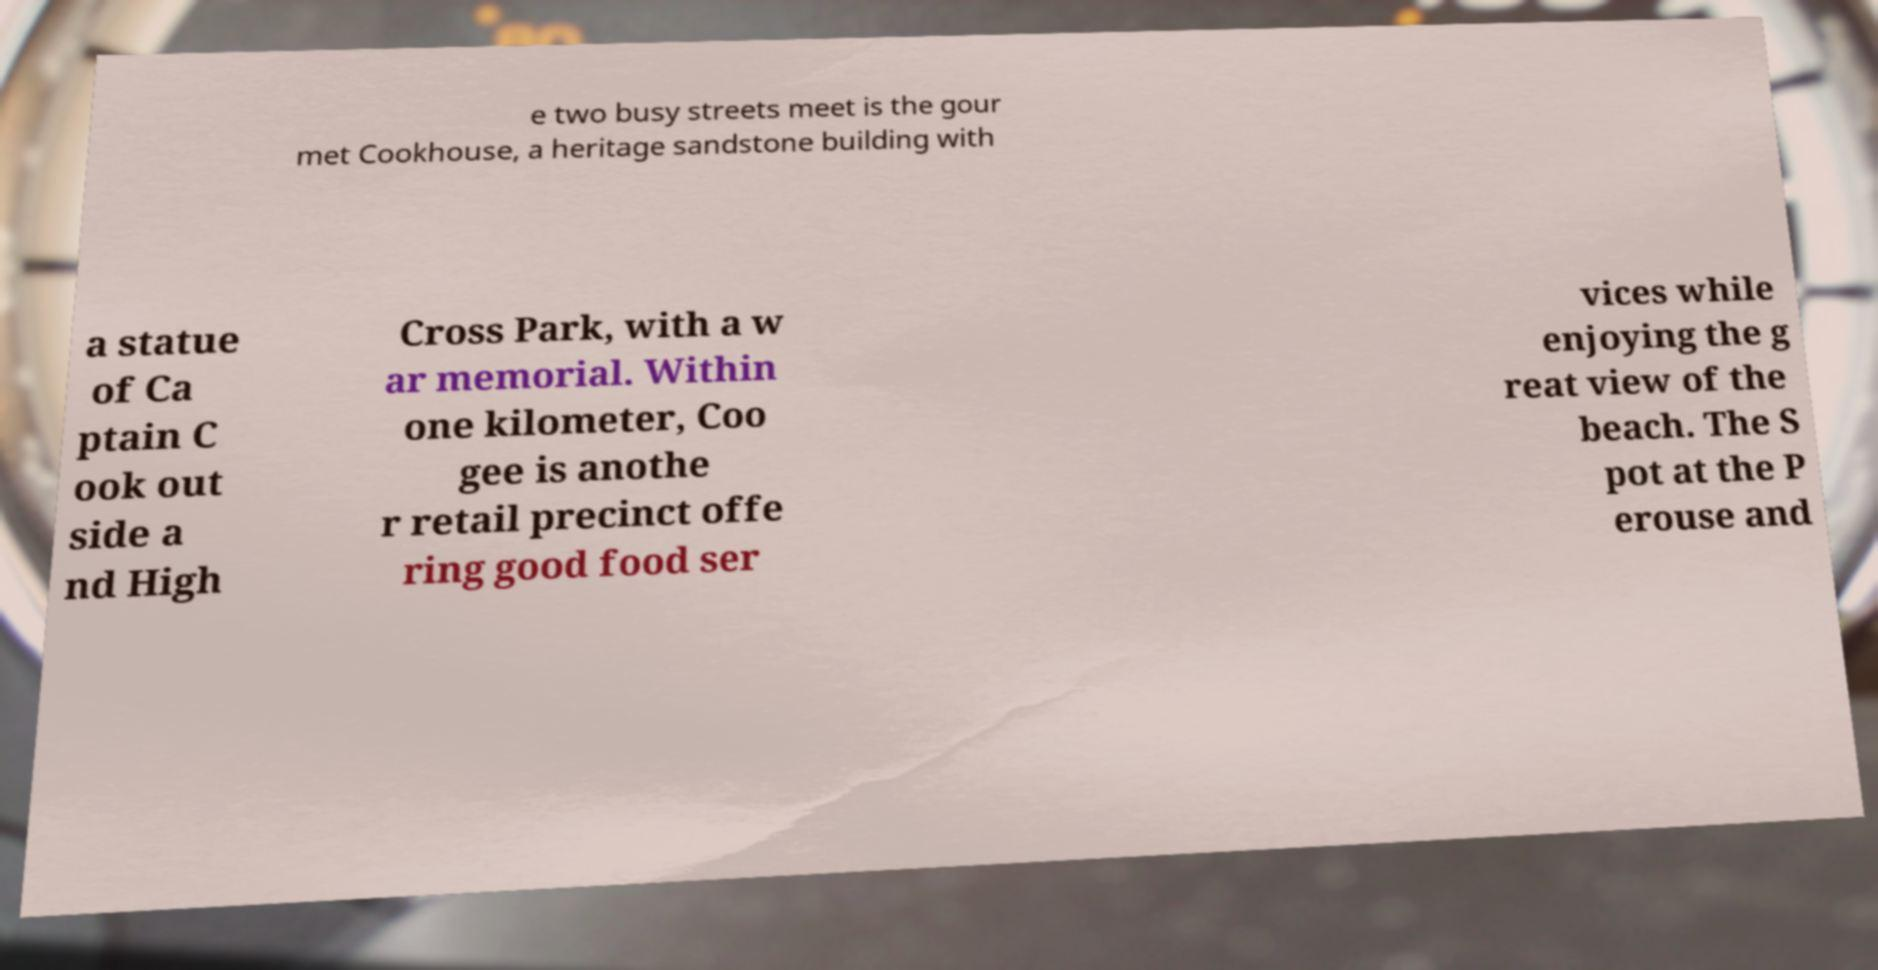Please identify and transcribe the text found in this image. e two busy streets meet is the gour met Cookhouse, a heritage sandstone building with a statue of Ca ptain C ook out side a nd High Cross Park, with a w ar memorial. Within one kilometer, Coo gee is anothe r retail precinct offe ring good food ser vices while enjoying the g reat view of the beach. The S pot at the P erouse and 